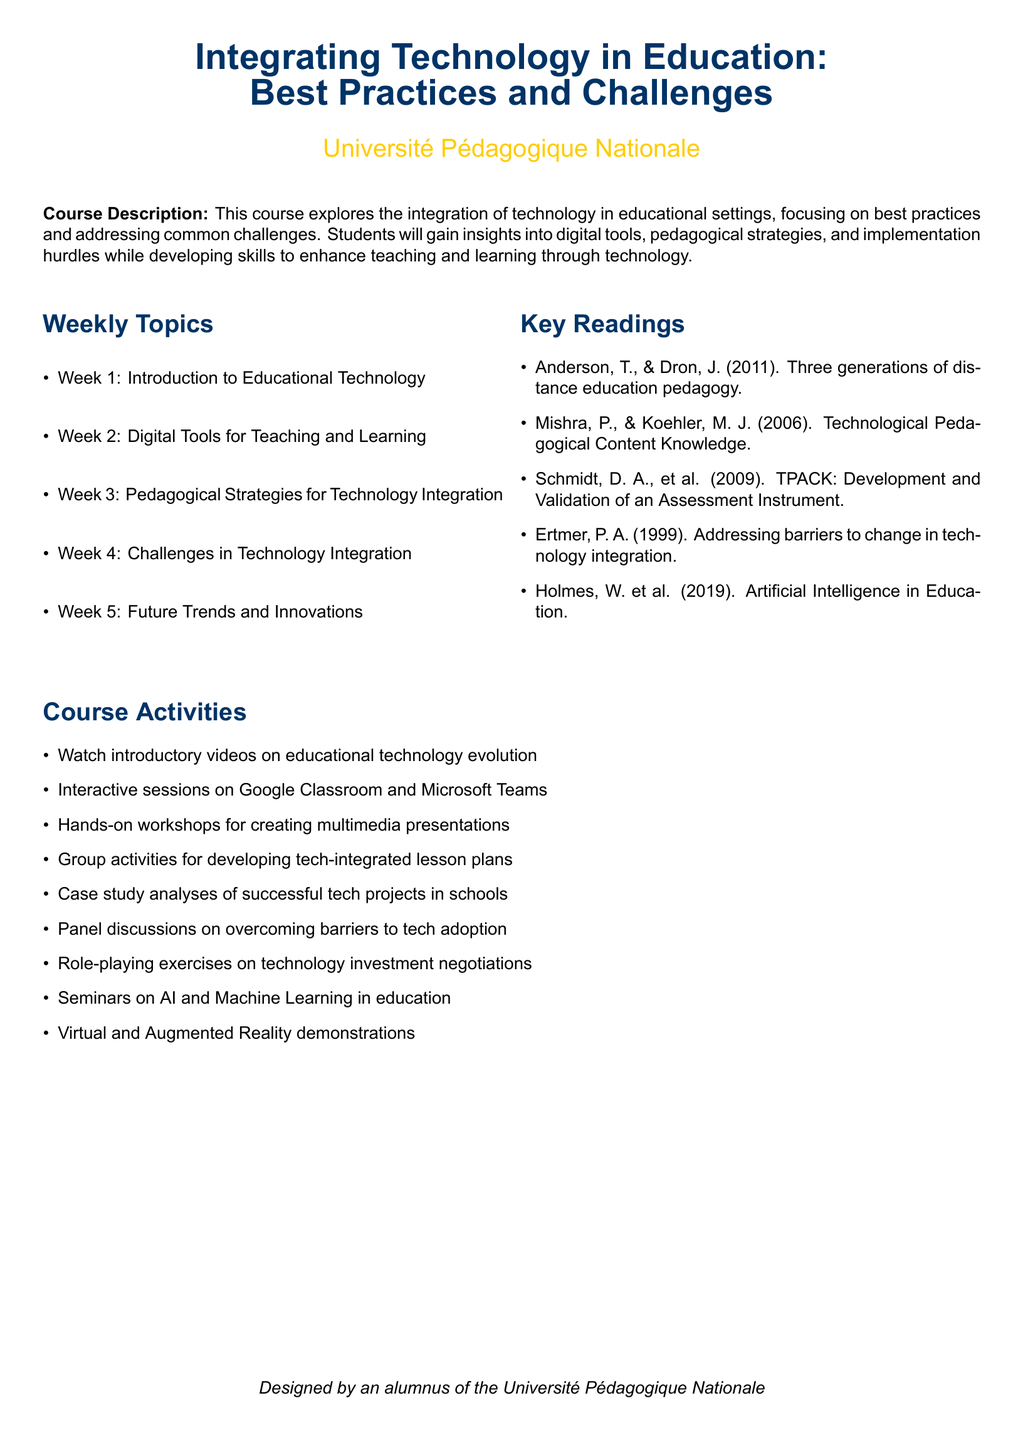What is the title of the course? The title of the course is given in the document as "Integrating Technology in Education: Best Practices and Challenges."
Answer: Integrating Technology in Education: Best Practices and Challenges Who is the author of the reading on "Artificial Intelligence in Education"? The author of the reading discussed is listed in the key readings section of the document.
Answer: Holmes, W. et al How many weeks are covered in the syllabus? The syllabus outlines the topics to be covered over a period of weeks.
Answer: 5 What is the focus of Week 4 in the course? Week 4 is specifically dedicated to discussing issues related to technology integration in education.
Answer: Challenges in Technology Integration What type of activities are included in the course? The document lists several course activities, indicating the interactive nature of the course.
Answer: Hands-on workshops for creating multimedia presentations What is the purpose of the course? The purpose of the course is described in the course description section.
Answer: To explore the integration of technology in educational settings What is one example of a technology discussed in the course activities? The course activities section provides examples of technologies that will be used in the course.
Answer: Google Classroom What reading discusses barriers to change in technology integration? One reading specifically addresses the issue of barriers in the context of technology integration.
Answer: Ertmer, P. A. (1999) What is a key theme addressed in the course regarding technology? The course examines various themes related to the adoption and use of technology in education.
Answer: Best practices and challenges 